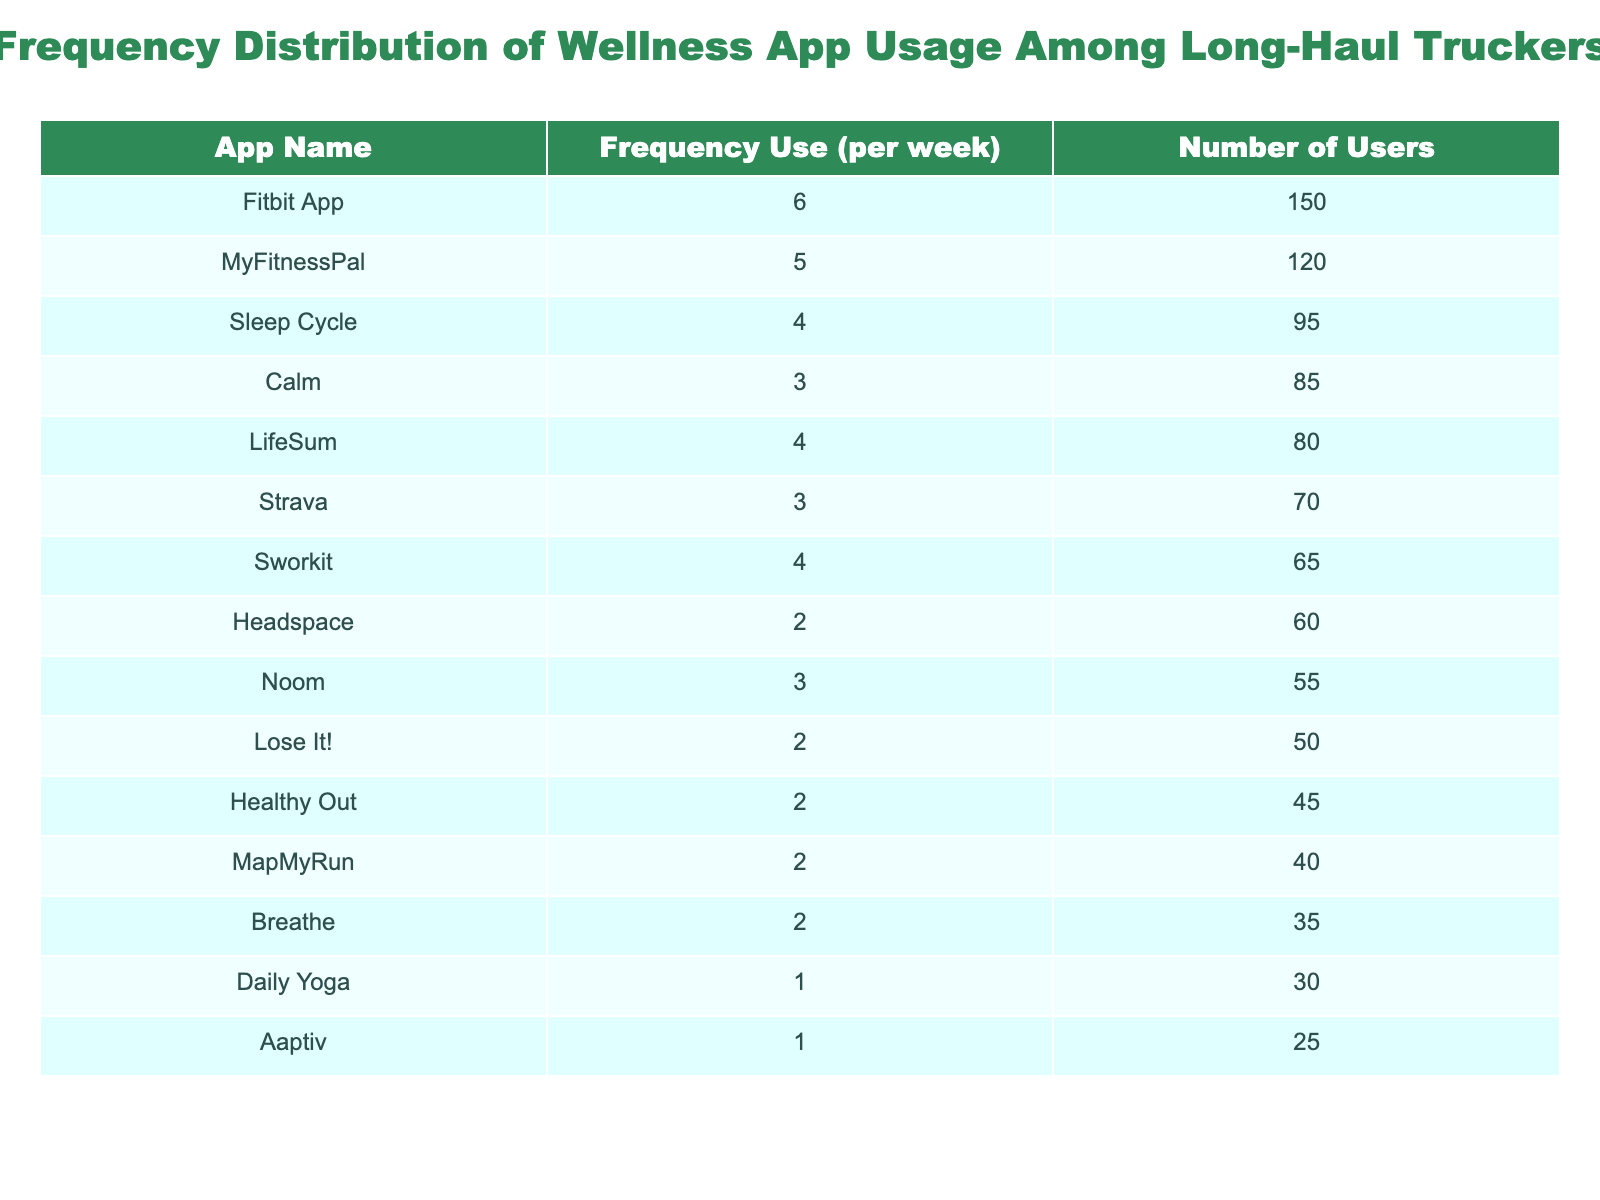What is the most frequently used wellness app among long-haul truckers? By reviewing the "Number of Users" column, we see that the Fitbit App has the highest number of users at 150.
Answer: Fitbit App How many truckers use Calm? The table shows that 85 truckers use the Calm app, which can be directly found in the "Number of Users" column.
Answer: 85 What is the average frequency of app usage across all wellness apps? To find the average, we sum the frequencies: (5 + 3 + 2 + 4 + 6 + 2 + 3 + 1 + 4 + 3 + 2 + 4 + 2 + 1 + 2) = 47. There are 15 apps, so the average frequency is 47/15 = 3.13.
Answer: 3.13 Is there any app used by less than 50 truckers? Yes, by scanning the "Number of Users" column, I can see that the Daily Yoga (30 users) and Aaptiv (25 users) apps are used by less than 50 truckers.
Answer: Yes Which app has a frequency use of 1 and how many users does it have? Looking at the table, the app with a frequency usage of 1 is Daily Yoga, and it has 30 users, as indicated in its corresponding line in the table.
Answer: Daily Yoga, 30 users What is the total number of users for apps that are used 3 times a week? The apps used three times a week are Calm, Strava, and Noom. Their users are 85, 70, and 55 respectively. The total is 85 + 70 + 55 = 210.
Answer: 210 Which frequency usage is least common, and which app corresponds to it? The least common frequency is 1, represented by the Aaptiv app which has 25 users. This was confirmed by checking the frequency values in the table.
Answer: 1, Aaptiv How many total users are there for apps used 2 or more times a week? Apps used 2 or more times a week are MyFitnessPal (120), Calm (85), Headspace (60), Sleep Cycle (95), Fitbit App (150), Strava (70), Noom (55), Healthy Out (45), LifeSum (80), and Lose It! (50). The total is 120 + 85 + 60 + 95 + 150 + 70 + 55 + 45 + 80 + 50 = 1050.
Answer: 1050 What percentage of users are using the Fitbit App relative to the total users listed in the table? The Fitbit App has 150 users. The total number of users across all apps can be calculated: 120 + 85 + 60 + 95 + 150 + 40 + 70 + 30 + 65 + 55 + 45 + 80 + 50 + 25 + 35 = 1,050. The percentage is (150/1050) * 100 = 14.29%.
Answer: 14.29% 